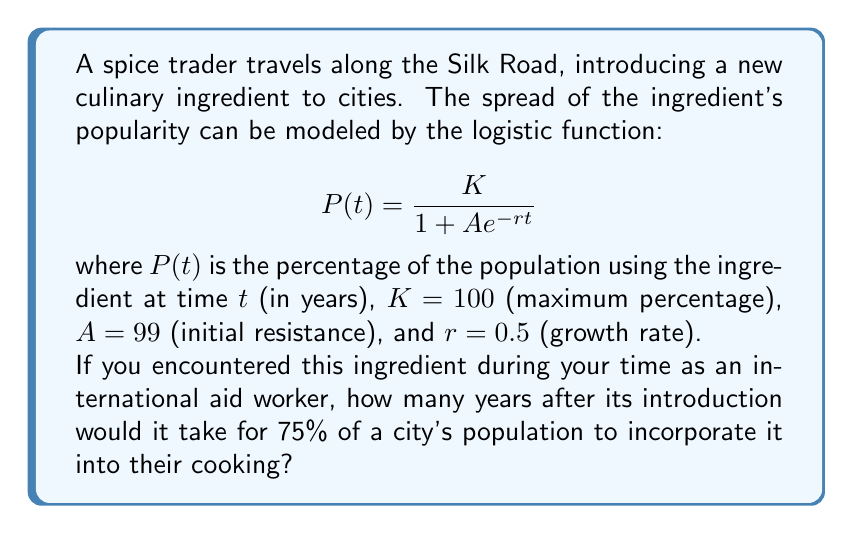Give your solution to this math problem. To solve this problem, we need to follow these steps:

1) We're given the logistic function:
   $$P(t) = \frac{K}{1 + Ae^{-rt}}$$

2) We know the values: $K = 100$, $A = 99$, $r = 0.5$, and we want to find $t$ when $P(t) = 75$.

3) Let's substitute these values into the equation:
   $$75 = \frac{100}{1 + 99e^{-0.5t}}$$

4) Multiply both sides by the denominator:
   $$75(1 + 99e^{-0.5t}) = 100$$

5) Distribute on the left side:
   $$75 + 7425e^{-0.5t} = 100$$

6) Subtract 75 from both sides:
   $$7425e^{-0.5t} = 25$$

7) Divide both sides by 7425:
   $$e^{-0.5t} = \frac{25}{7425} \approx 0.003367$$

8) Take the natural log of both sides:
   $$-0.5t = \ln(0.003367) \approx -5.6938$$

9) Divide both sides by -0.5:
   $$t = \frac{5.6938}{0.5} \approx 11.3876$$

Therefore, it would take approximately 11.39 years for 75% of the population to incorporate the new ingredient into their cooking.
Answer: 11.39 years 